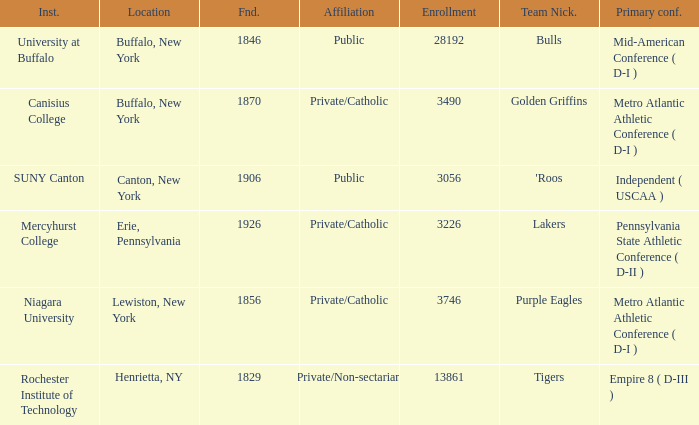Could you parse the entire table? {'header': ['Inst.', 'Location', 'Fnd.', 'Affiliation', 'Enrollment', 'Team Nick.', 'Primary conf.'], 'rows': [['University at Buffalo', 'Buffalo, New York', '1846', 'Public', '28192', 'Bulls', 'Mid-American Conference ( D-I )'], ['Canisius College', 'Buffalo, New York', '1870', 'Private/Catholic', '3490', 'Golden Griffins', 'Metro Atlantic Athletic Conference ( D-I )'], ['SUNY Canton', 'Canton, New York', '1906', 'Public', '3056', "'Roos", 'Independent ( USCAA )'], ['Mercyhurst College', 'Erie, Pennsylvania', '1926', 'Private/Catholic', '3226', 'Lakers', 'Pennsylvania State Athletic Conference ( D-II )'], ['Niagara University', 'Lewiston, New York', '1856', 'Private/Catholic', '3746', 'Purple Eagles', 'Metro Atlantic Athletic Conference ( D-I )'], ['Rochester Institute of Technology', 'Henrietta, NY', '1829', 'Private/Non-sectarian', '13861', 'Tigers', 'Empire 8 ( D-III )']]} What kind of school is Canton, New York? Public. 